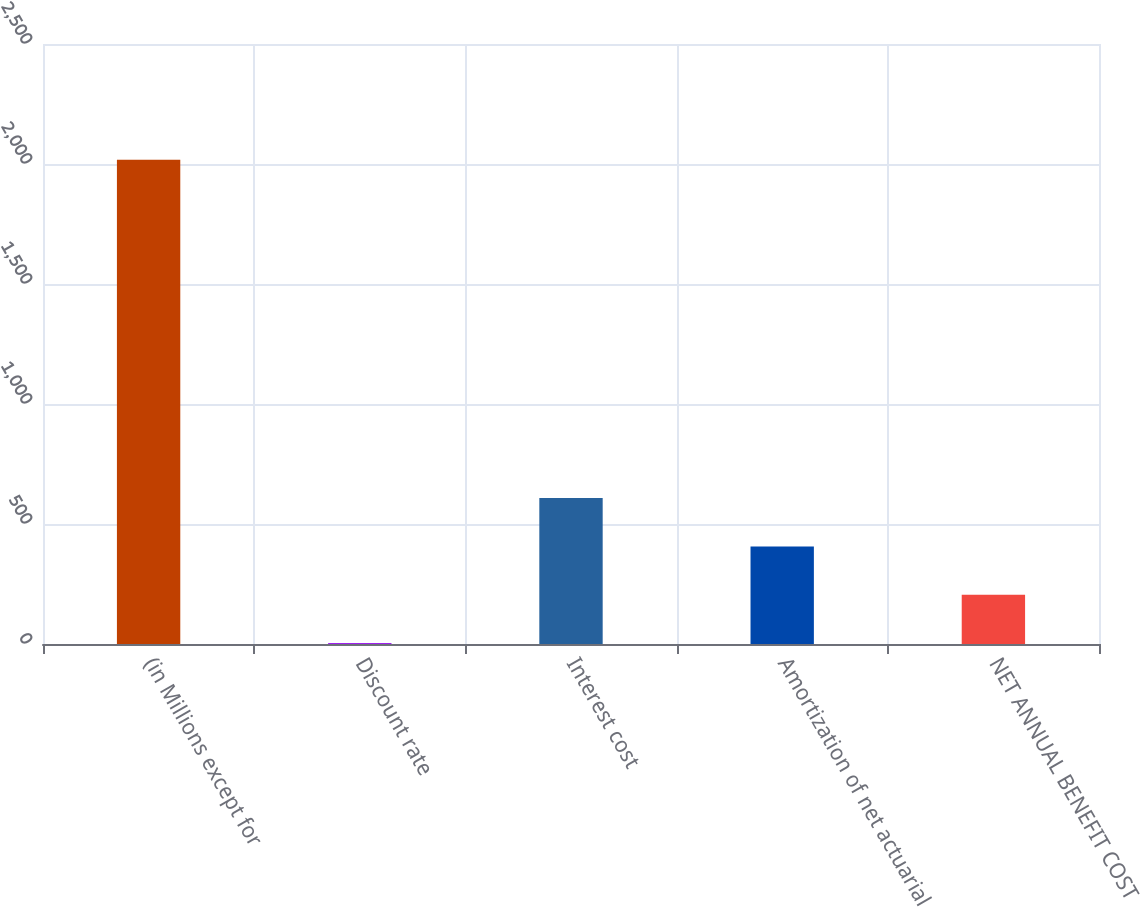Convert chart. <chart><loc_0><loc_0><loc_500><loc_500><bar_chart><fcel>(in Millions except for<fcel>Discount rate<fcel>Interest cost<fcel>Amortization of net actuarial<fcel>NET ANNUAL BENEFIT COST<nl><fcel>2018<fcel>3.68<fcel>607.97<fcel>406.54<fcel>205.11<nl></chart> 